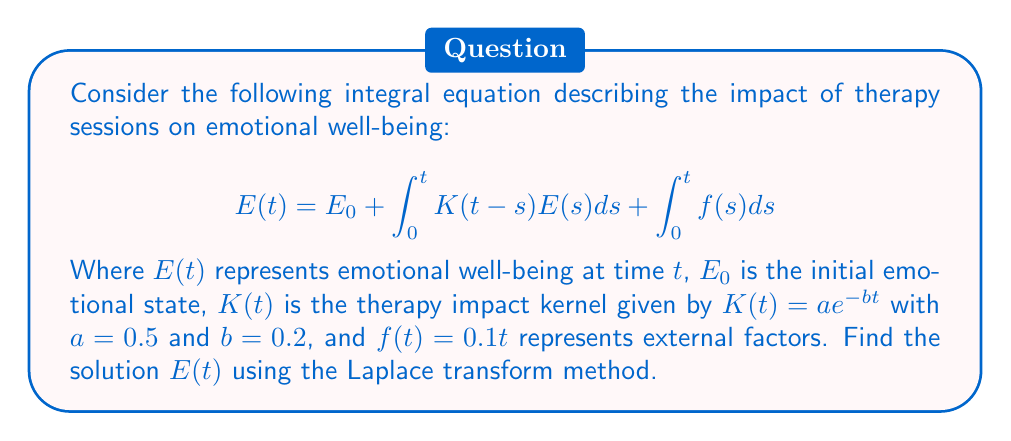What is the answer to this math problem? 1. Take the Laplace transform of both sides of the equation:
   $$\mathcal{L}\{E(t)\} = \mathcal{L}\{E_0\} + \mathcal{L}\{\int_0^t K(t-s)E(s)ds\} + \mathcal{L}\{\int_0^t f(s)ds\}$$

2. Apply the Laplace transform properties:
   $$\hat{E}(s) = \frac{E_0}{s} + \hat{K}(s)\hat{E}(s) + \frac{\hat{f}(s)}{s}$$

3. Calculate $\hat{K}(s)$ and $\hat{f}(s)$:
   $$\hat{K}(s) = \mathcal{L}\{ae^{-bt}\} = \frac{a}{s+b} = \frac{0.5}{s+0.2}$$
   $$\hat{f}(s) = \mathcal{L}\{0.1t\} = \frac{0.1}{s^2}$$

4. Substitute these into the equation:
   $$\hat{E}(s) = \frac{E_0}{s} + \frac{0.5}{s+0.2}\hat{E}(s) + \frac{0.1}{s^3}$$

5. Solve for $\hat{E}(s)$:
   $$\hat{E}(s)(1 - \frac{0.5}{s+0.2}) = \frac{E_0}{s} + \frac{0.1}{s^3}$$
   $$\hat{E}(s) = \frac{E_0(s+0.2) + 0.1s^{-2}(s+0.2)}{s(s+0.2) - 0.5}$$

6. Simplify:
   $$\hat{E}(s) = \frac{E_0s + 0.2E_0 + 0.1s^{-2} + 0.02s^{-2}}{s^2 + 0.2s - 0.5}$$

7. Take the inverse Laplace transform to get $E(t)$:
   $$E(t) = \mathcal{L}^{-1}\{\hat{E}(s)\} = E_0(0.8e^{0.5t} + 0.2e^{-0.7t}) + 0.1t + 0.02 + 0.14(e^{0.5t} - e^{-0.7t})$$

8. Simplify the final expression:
   $$E(t) = (0.8E_0 + 0.14)e^{0.5t} + (0.2E_0 - 0.14)e^{-0.7t} + 0.1t + 0.02$$
Answer: $E(t) = (0.8E_0 + 0.14)e^{0.5t} + (0.2E_0 - 0.14)e^{-0.7t} + 0.1t + 0.02$ 